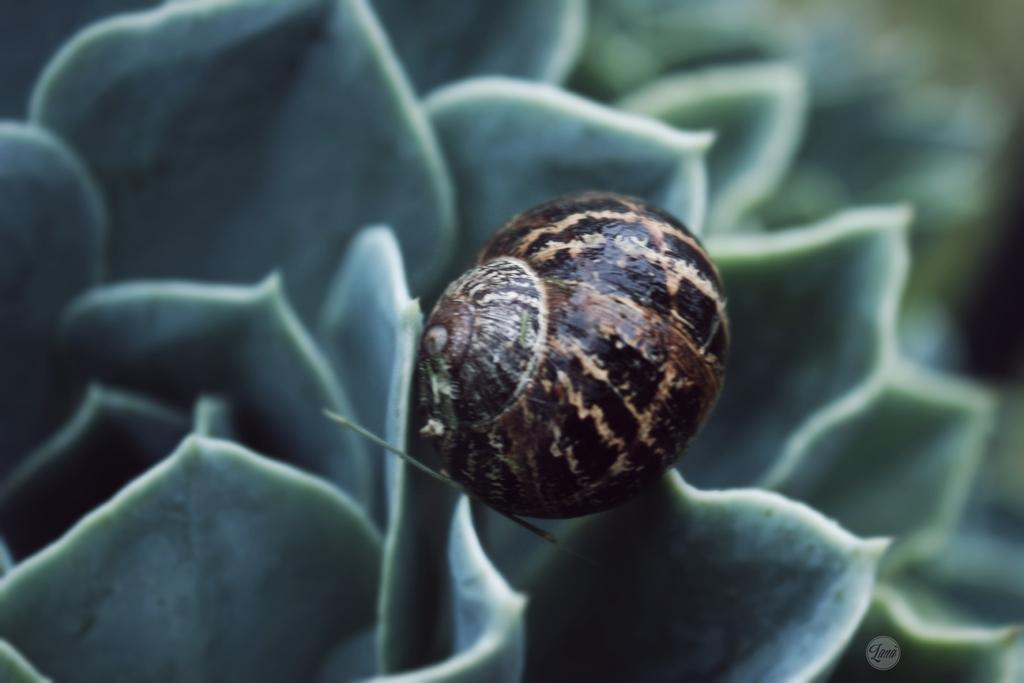Can you describe this image briefly? In the center of the image there is a flower. There is some insect on the flower. 